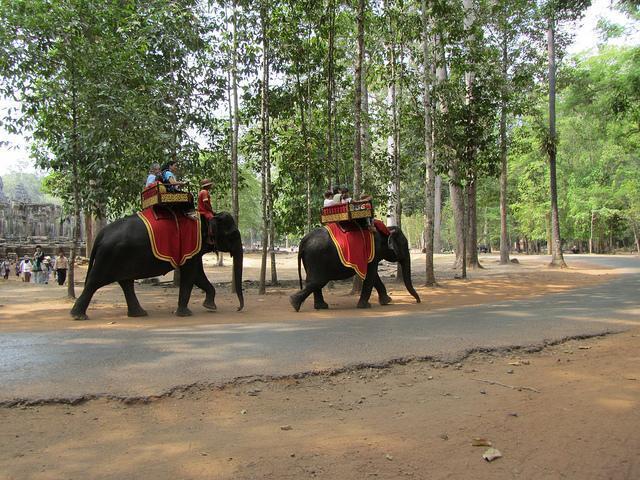How many elephants in the picture?
Give a very brief answer. 2. How many elephants are there?
Give a very brief answer. 2. 